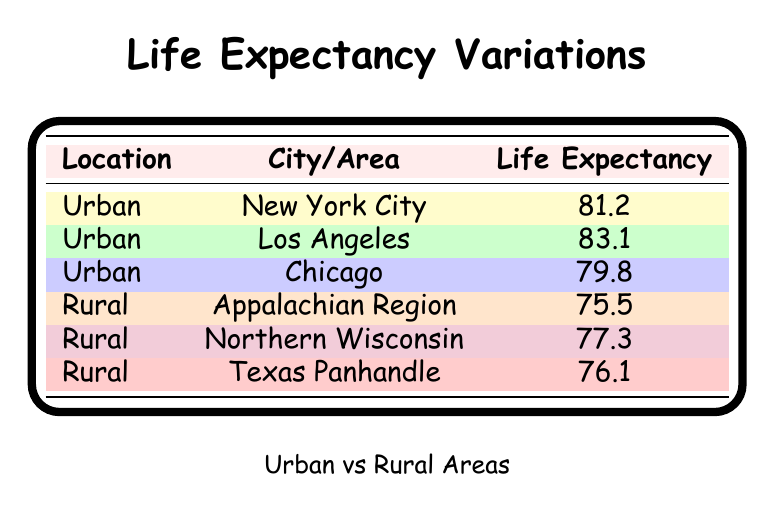What is the life expectancy in Los Angeles? The table lists Los Angeles as an urban location with a life expectancy of 83.1 years.
Answer: 83.1 What is the life expectancy in the Appalachian Region? The Appalachian Region is identified in the table as a rural area with a life expectancy of 75.5 years.
Answer: 75.5 Which urban area has the lowest life expectancy? By examining the urban locations, Chicago has the lowest life expectancy at 79.8 years, while New York City and Los Angeles have higher values.
Answer: Chicago What is the average life expectancy for urban areas listed? The urban life expectancy values are 81.2 (New York City), 83.1 (Los Angeles), and 79.8 (Chicago). The sum is 81.2 + 83.1 + 79.8 = 244.1. There are 3 urban areas, so average is 244.1 / 3 = 81.367.
Answer: 81.37 Is the life expectancy in Northern Wisconsin greater than that in the Texas Panhandle? Northern Wisconsin has a life expectancy of 77.3 years, and Texas Panhandle has 76.1 years, so Northern Wisconsin has a greater life expectancy than Texas Panhandle.
Answer: Yes Which type of area has a generally higher life expectancy, urban or rural? By comparing the highest urban life expectancy of 83.1 (Los Angeles) to the highest rural life expectancy of 77.3 (Northern Wisconsin), it's clear that urban areas generally have higher life expectancy.
Answer: Urban If you combine the life expectancy of all areas, what is the total? The sum of life expectancy values is as follows: 81.2 (NYC) + 83.1 (LA) + 79.8 (Chicago) + 75.5 (Appalachian) + 77.3 (Northern Wisconsin) + 76.1 (Texas Panhandle) = 493.
Answer: 493 What is the difference in life expectancy between the highest urban and the highest rural areas? The highest urban life expectancy is 83.1 (Los Angeles) and the highest rural life expectancy is 77.3 (Northern Wisconsin). The difference is 83.1 - 77.3 = 5.8.
Answer: 5.8 Which city has a life expectancy of 81.2 years? The table shows New York City has a life expectancy of 81.2 years.
Answer: New York City 